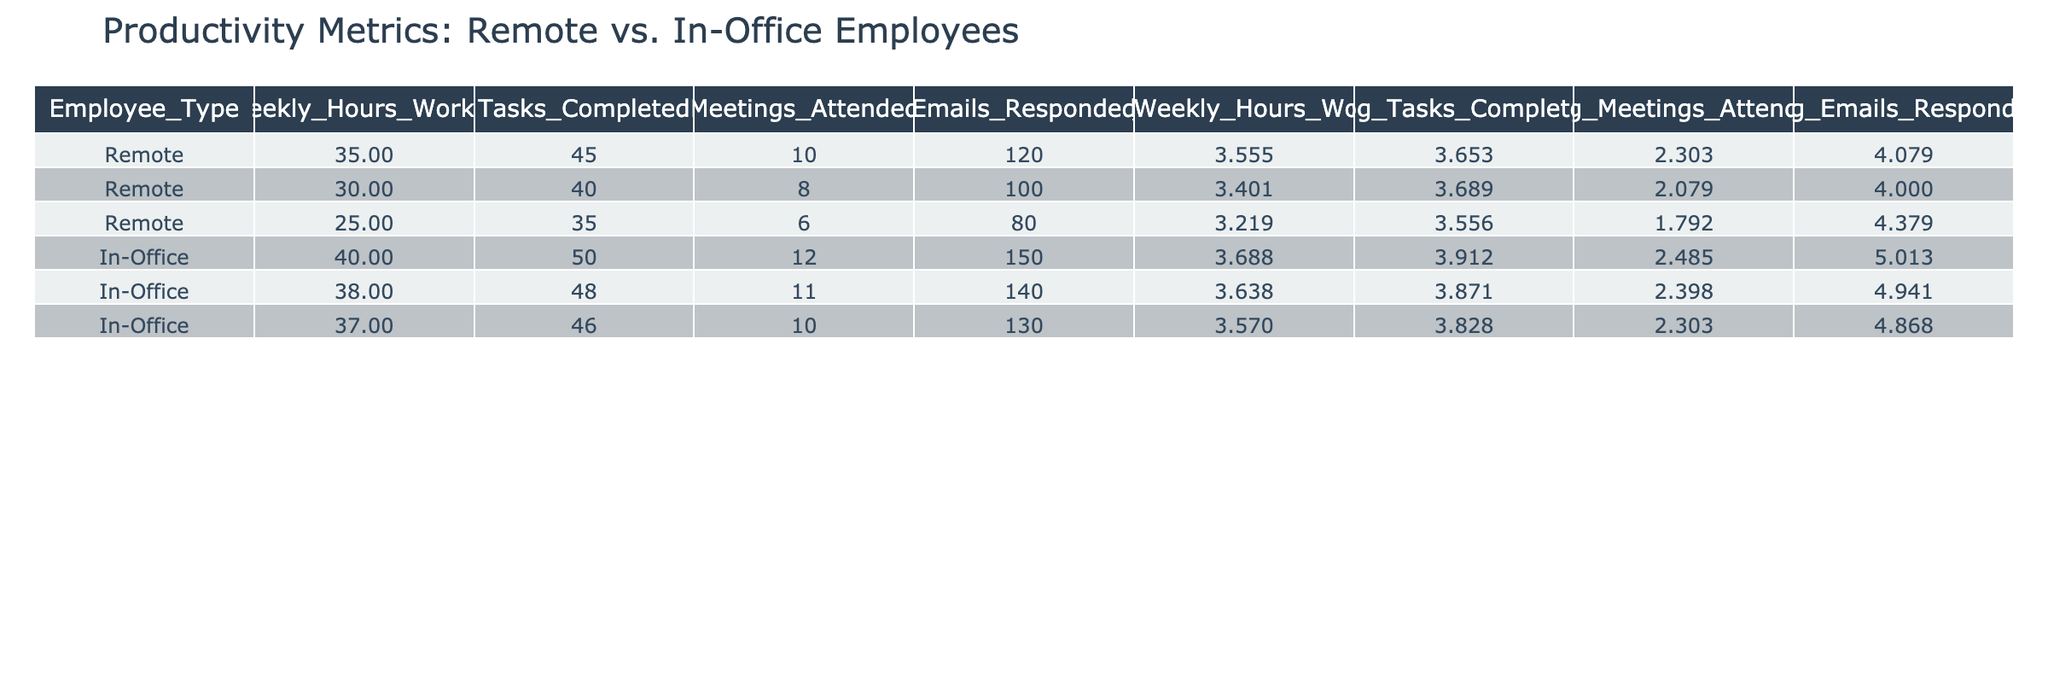What is the total number of tasks completed by remote employees? To find the total number of tasks completed, we will sum the 'Tasks Completed' column for remote employees. The values are 45, 40, and 35. Thus, 45 + 40 + 35 = 120.
Answer: 120 What is the average number of meetings attended by in-office employees? There are three in-office employees, and the values for meetings attended are 12, 11, and 10. To find the average, we sum these values (12 + 11 + 10 = 33) and divide by 3, which gives us 33 / 3 = 11.
Answer: 11 Did remote employees respond to more emails than in-office employees? To answer this, we need to compare the total emails responded by both groups. Remote employees responded 120 + 100 + 80 = 300 emails, while in-office employees responded 150 + 140 + 130 = 420 emails. Since 300 is less than 420, remote employees did not respond to more emails.
Answer: No What is the difference in weekly hours worked between remote and in-office employees on average? First, we need to calculate the average weekly hours worked for each group. For remote, (35 + 30 + 25) / 3 = 30. For in-office, (40 + 38 + 37) / 3 = 38.33. Now, we find the difference: 38.33 - 30 = 8.33 hours.
Answer: 8.33 Which employee type has a higher average log value for emails responded? We calculate the average log value for emails responded for each employee type. Remote: (4.079 + 4.000 + 4.379) / 3 = 4.152. In-office: (5.013 + 4.941 + 4.868) / 3 = 4.941. Since 4.941 is greater than 4.152, in-office employees have a higher average log value for emails responded.
Answer: In-office employees 